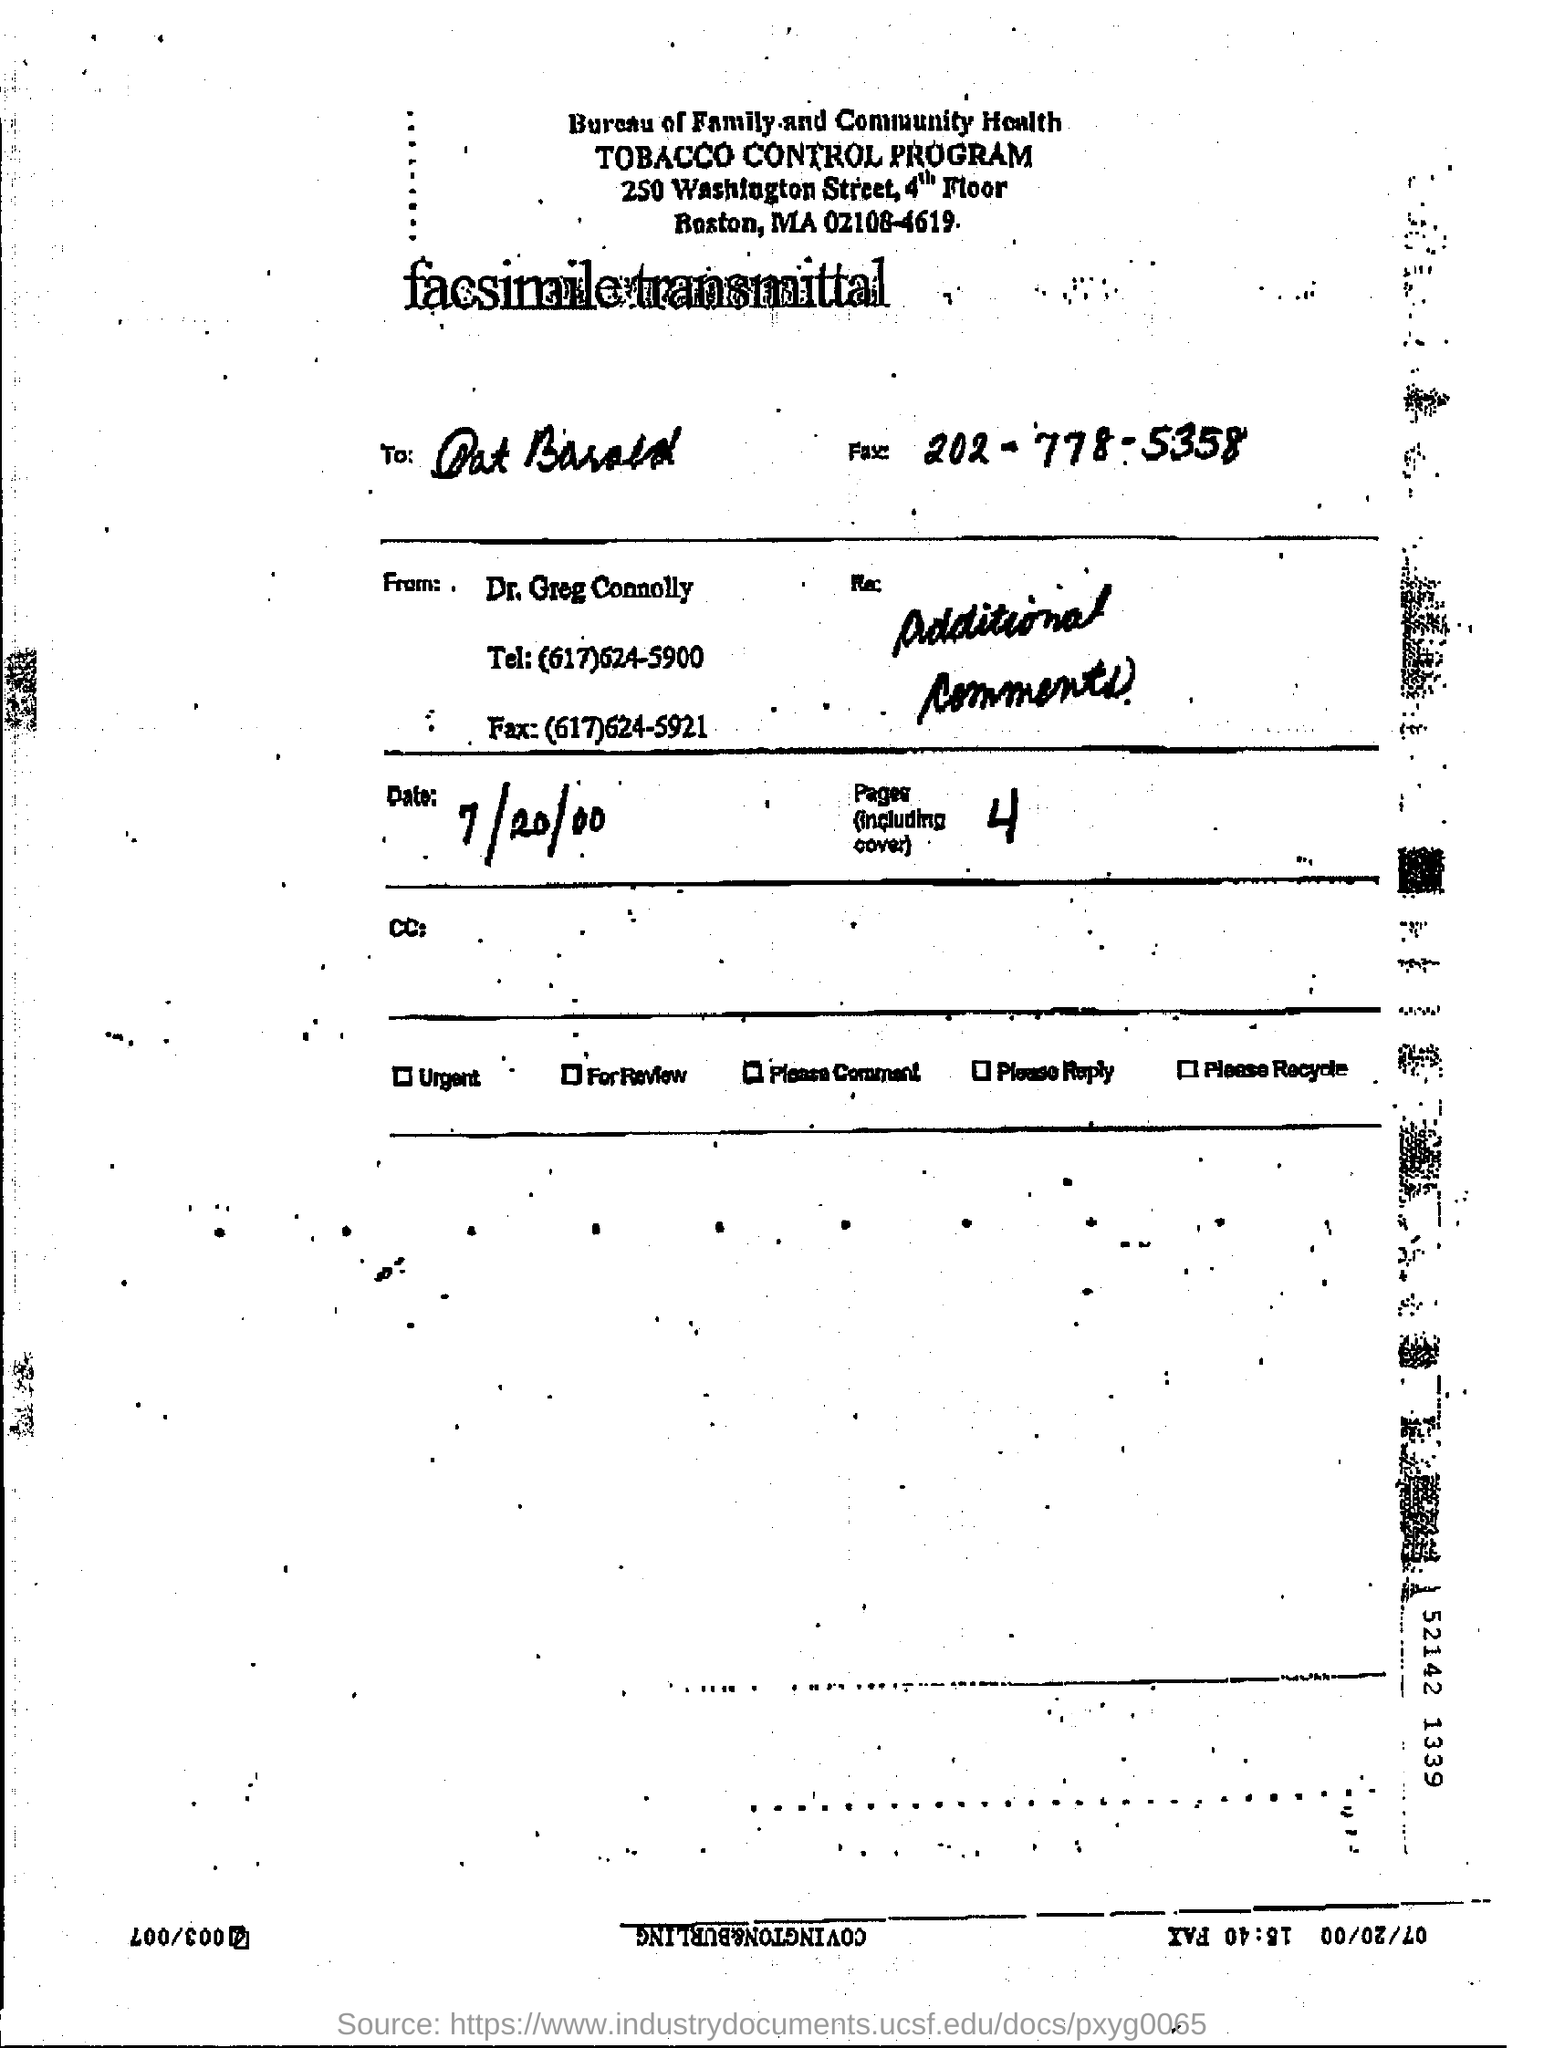What is the main subject of the document? The main subject of the document is related to the Tobacco Control Program from the Bureau of Family and Community Health. 